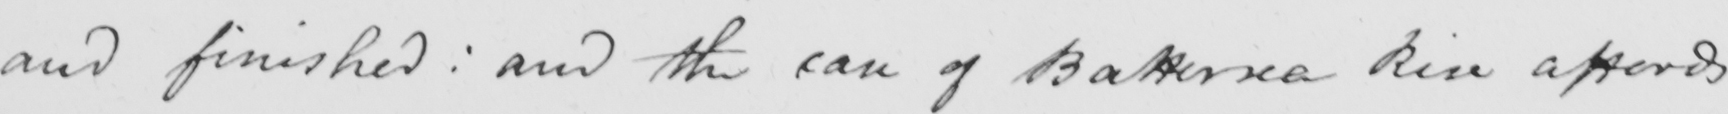Please provide the text content of this handwritten line. and finished :  and the case of Battersea Rise affords 